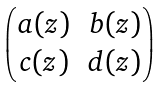Convert formula to latex. <formula><loc_0><loc_0><loc_500><loc_500>\begin{pmatrix} a ( z ) & b ( z ) \\ c ( z ) & d ( z ) \end{pmatrix}</formula> 